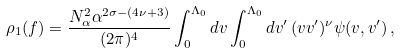Convert formula to latex. <formula><loc_0><loc_0><loc_500><loc_500>\rho _ { 1 } ( f ) = \frac { N _ { \alpha } ^ { 2 } \alpha ^ { 2 \sigma - ( 4 \nu + 3 ) } } { ( 2 \pi ) ^ { 4 } } \int _ { 0 } ^ { \Lambda _ { 0 } } d v \int _ { 0 } ^ { \Lambda _ { 0 } } d v ^ { \prime } \, ( v v ^ { \prime } ) ^ { \nu } \psi ( v , v ^ { \prime } ) \, ,</formula> 